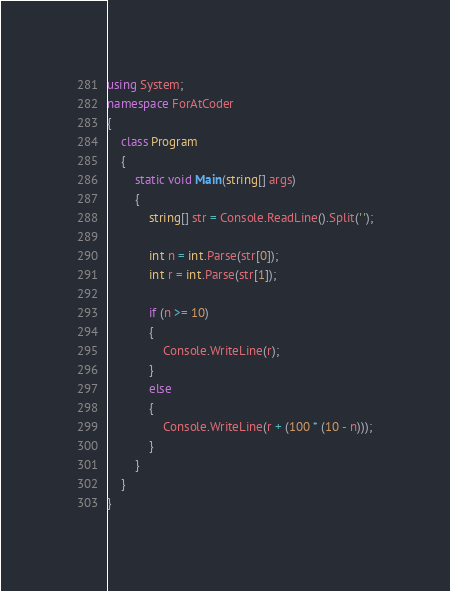Convert code to text. <code><loc_0><loc_0><loc_500><loc_500><_C#_>using System;
namespace ForAtCoder
{
    class Program
    {
        static void Main(string[] args)
        {
            string[] str = Console.ReadLine().Split(' ');

            int n = int.Parse(str[0]);
            int r = int.Parse(str[1]);

            if (n >= 10)
            {
                Console.WriteLine(r);
            }
            else
            {
                Console.WriteLine(r + (100 * (10 - n)));
            }
        }
    }
}
</code> 